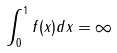<formula> <loc_0><loc_0><loc_500><loc_500>\int _ { 0 } ^ { 1 } f ( x ) d x = \infty</formula> 